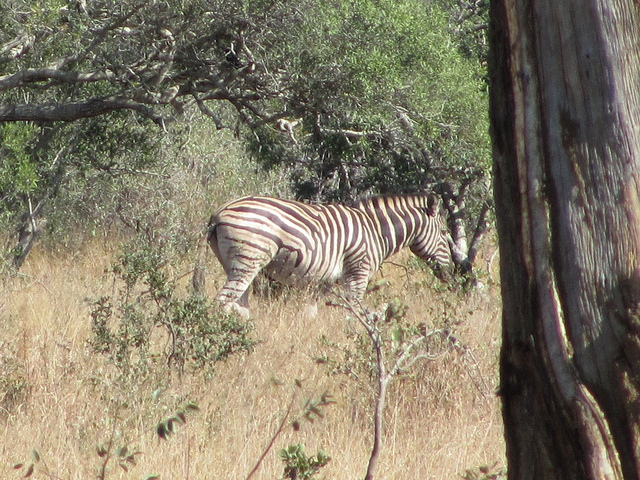<image>What color is the door? There is no door in the image. What color is the door? I don't know the color of the door. It is not visible in the image. 